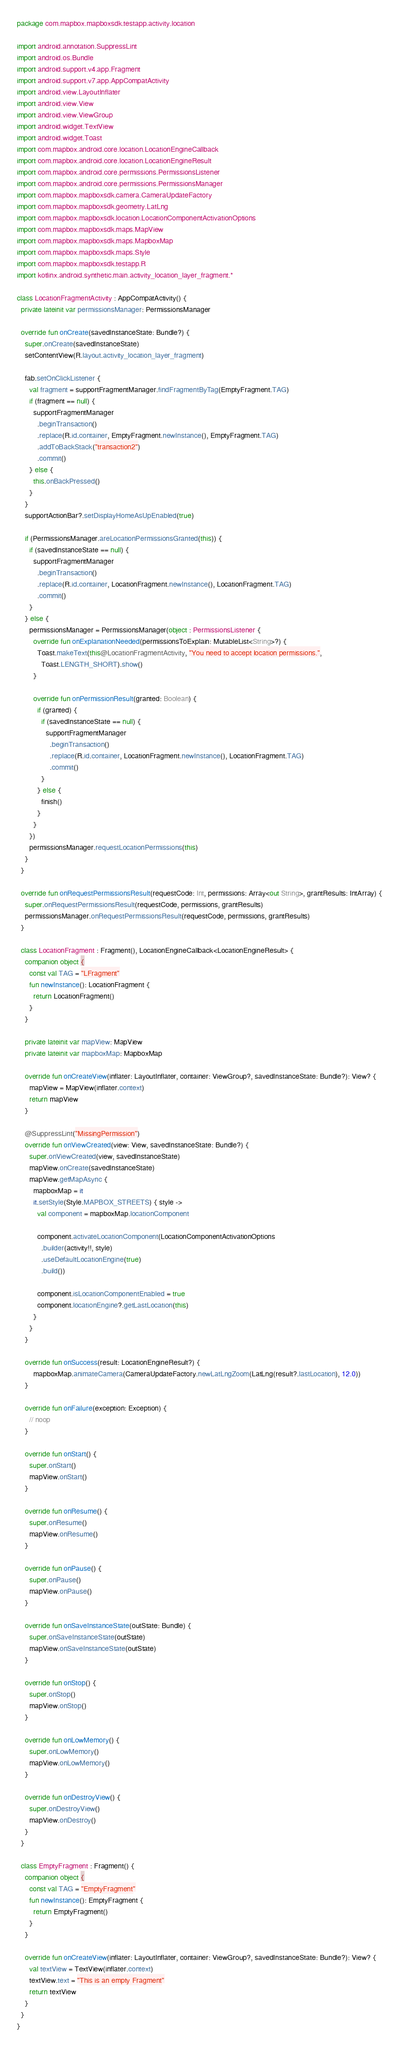Convert code to text. <code><loc_0><loc_0><loc_500><loc_500><_Kotlin_>package com.mapbox.mapboxsdk.testapp.activity.location

import android.annotation.SuppressLint
import android.os.Bundle
import android.support.v4.app.Fragment
import android.support.v7.app.AppCompatActivity
import android.view.LayoutInflater
import android.view.View
import android.view.ViewGroup
import android.widget.TextView
import android.widget.Toast
import com.mapbox.android.core.location.LocationEngineCallback
import com.mapbox.android.core.location.LocationEngineResult
import com.mapbox.android.core.permissions.PermissionsListener
import com.mapbox.android.core.permissions.PermissionsManager
import com.mapbox.mapboxsdk.camera.CameraUpdateFactory
import com.mapbox.mapboxsdk.geometry.LatLng
import com.mapbox.mapboxsdk.location.LocationComponentActivationOptions
import com.mapbox.mapboxsdk.maps.MapView
import com.mapbox.mapboxsdk.maps.MapboxMap
import com.mapbox.mapboxsdk.maps.Style
import com.mapbox.mapboxsdk.testapp.R
import kotlinx.android.synthetic.main.activity_location_layer_fragment.*

class LocationFragmentActivity : AppCompatActivity() {
  private lateinit var permissionsManager: PermissionsManager

  override fun onCreate(savedInstanceState: Bundle?) {
    super.onCreate(savedInstanceState)
    setContentView(R.layout.activity_location_layer_fragment)

    fab.setOnClickListener {
      val fragment = supportFragmentManager.findFragmentByTag(EmptyFragment.TAG)
      if (fragment == null) {
        supportFragmentManager
          .beginTransaction()
          .replace(R.id.container, EmptyFragment.newInstance(), EmptyFragment.TAG)
          .addToBackStack("transaction2")
          .commit()
      } else {
        this.onBackPressed()
      }
    }
    supportActionBar?.setDisplayHomeAsUpEnabled(true)

    if (PermissionsManager.areLocationPermissionsGranted(this)) {
      if (savedInstanceState == null) {
        supportFragmentManager
          .beginTransaction()
          .replace(R.id.container, LocationFragment.newInstance(), LocationFragment.TAG)
          .commit()
      }
    } else {
      permissionsManager = PermissionsManager(object : PermissionsListener {
        override fun onExplanationNeeded(permissionsToExplain: MutableList<String>?) {
          Toast.makeText(this@LocationFragmentActivity, "You need to accept location permissions.",
            Toast.LENGTH_SHORT).show()
        }

        override fun onPermissionResult(granted: Boolean) {
          if (granted) {
            if (savedInstanceState == null) {
              supportFragmentManager
                .beginTransaction()
                .replace(R.id.container, LocationFragment.newInstance(), LocationFragment.TAG)
                .commit()
            }
          } else {
            finish()
          }
        }
      })
      permissionsManager.requestLocationPermissions(this)
    }
  }

  override fun onRequestPermissionsResult(requestCode: Int, permissions: Array<out String>, grantResults: IntArray) {
    super.onRequestPermissionsResult(requestCode, permissions, grantResults)
    permissionsManager.onRequestPermissionsResult(requestCode, permissions, grantResults)
  }

  class LocationFragment : Fragment(), LocationEngineCallback<LocationEngineResult> {
    companion object {
      const val TAG = "LFragment"
      fun newInstance(): LocationFragment {
        return LocationFragment()
      }
    }

    private lateinit var mapView: MapView
    private lateinit var mapboxMap: MapboxMap

    override fun onCreateView(inflater: LayoutInflater, container: ViewGroup?, savedInstanceState: Bundle?): View? {
      mapView = MapView(inflater.context)
      return mapView
    }

    @SuppressLint("MissingPermission")
    override fun onViewCreated(view: View, savedInstanceState: Bundle?) {
      super.onViewCreated(view, savedInstanceState)
      mapView.onCreate(savedInstanceState)
      mapView.getMapAsync {
        mapboxMap = it
        it.setStyle(Style.MAPBOX_STREETS) { style ->
          val component = mapboxMap.locationComponent

          component.activateLocationComponent(LocationComponentActivationOptions
            .builder(activity!!, style)
            .useDefaultLocationEngine(true)
            .build())

          component.isLocationComponentEnabled = true
          component.locationEngine?.getLastLocation(this)
        }
      }
    }

    override fun onSuccess(result: LocationEngineResult?) {
        mapboxMap.animateCamera(CameraUpdateFactory.newLatLngZoom(LatLng(result?.lastLocation), 12.0))
    }

    override fun onFailure(exception: Exception) {
      // noop
    }

    override fun onStart() {
      super.onStart()
      mapView.onStart()
    }

    override fun onResume() {
      super.onResume()
      mapView.onResume()
    }

    override fun onPause() {
      super.onPause()
      mapView.onPause()
    }

    override fun onSaveInstanceState(outState: Bundle) {
      super.onSaveInstanceState(outState)
      mapView.onSaveInstanceState(outState)
    }

    override fun onStop() {
      super.onStop()
      mapView.onStop()
    }

    override fun onLowMemory() {
      super.onLowMemory()
      mapView.onLowMemory()
    }

    override fun onDestroyView() {
      super.onDestroyView()
      mapView.onDestroy()
    }
  }

  class EmptyFragment : Fragment() {
    companion object {
      const val TAG = "EmptyFragment"
      fun newInstance(): EmptyFragment {
        return EmptyFragment()
      }
    }

    override fun onCreateView(inflater: LayoutInflater, container: ViewGroup?, savedInstanceState: Bundle?): View? {
      val textView = TextView(inflater.context)
      textView.text = "This is an empty Fragment"
      return textView
    }
  }
}</code> 